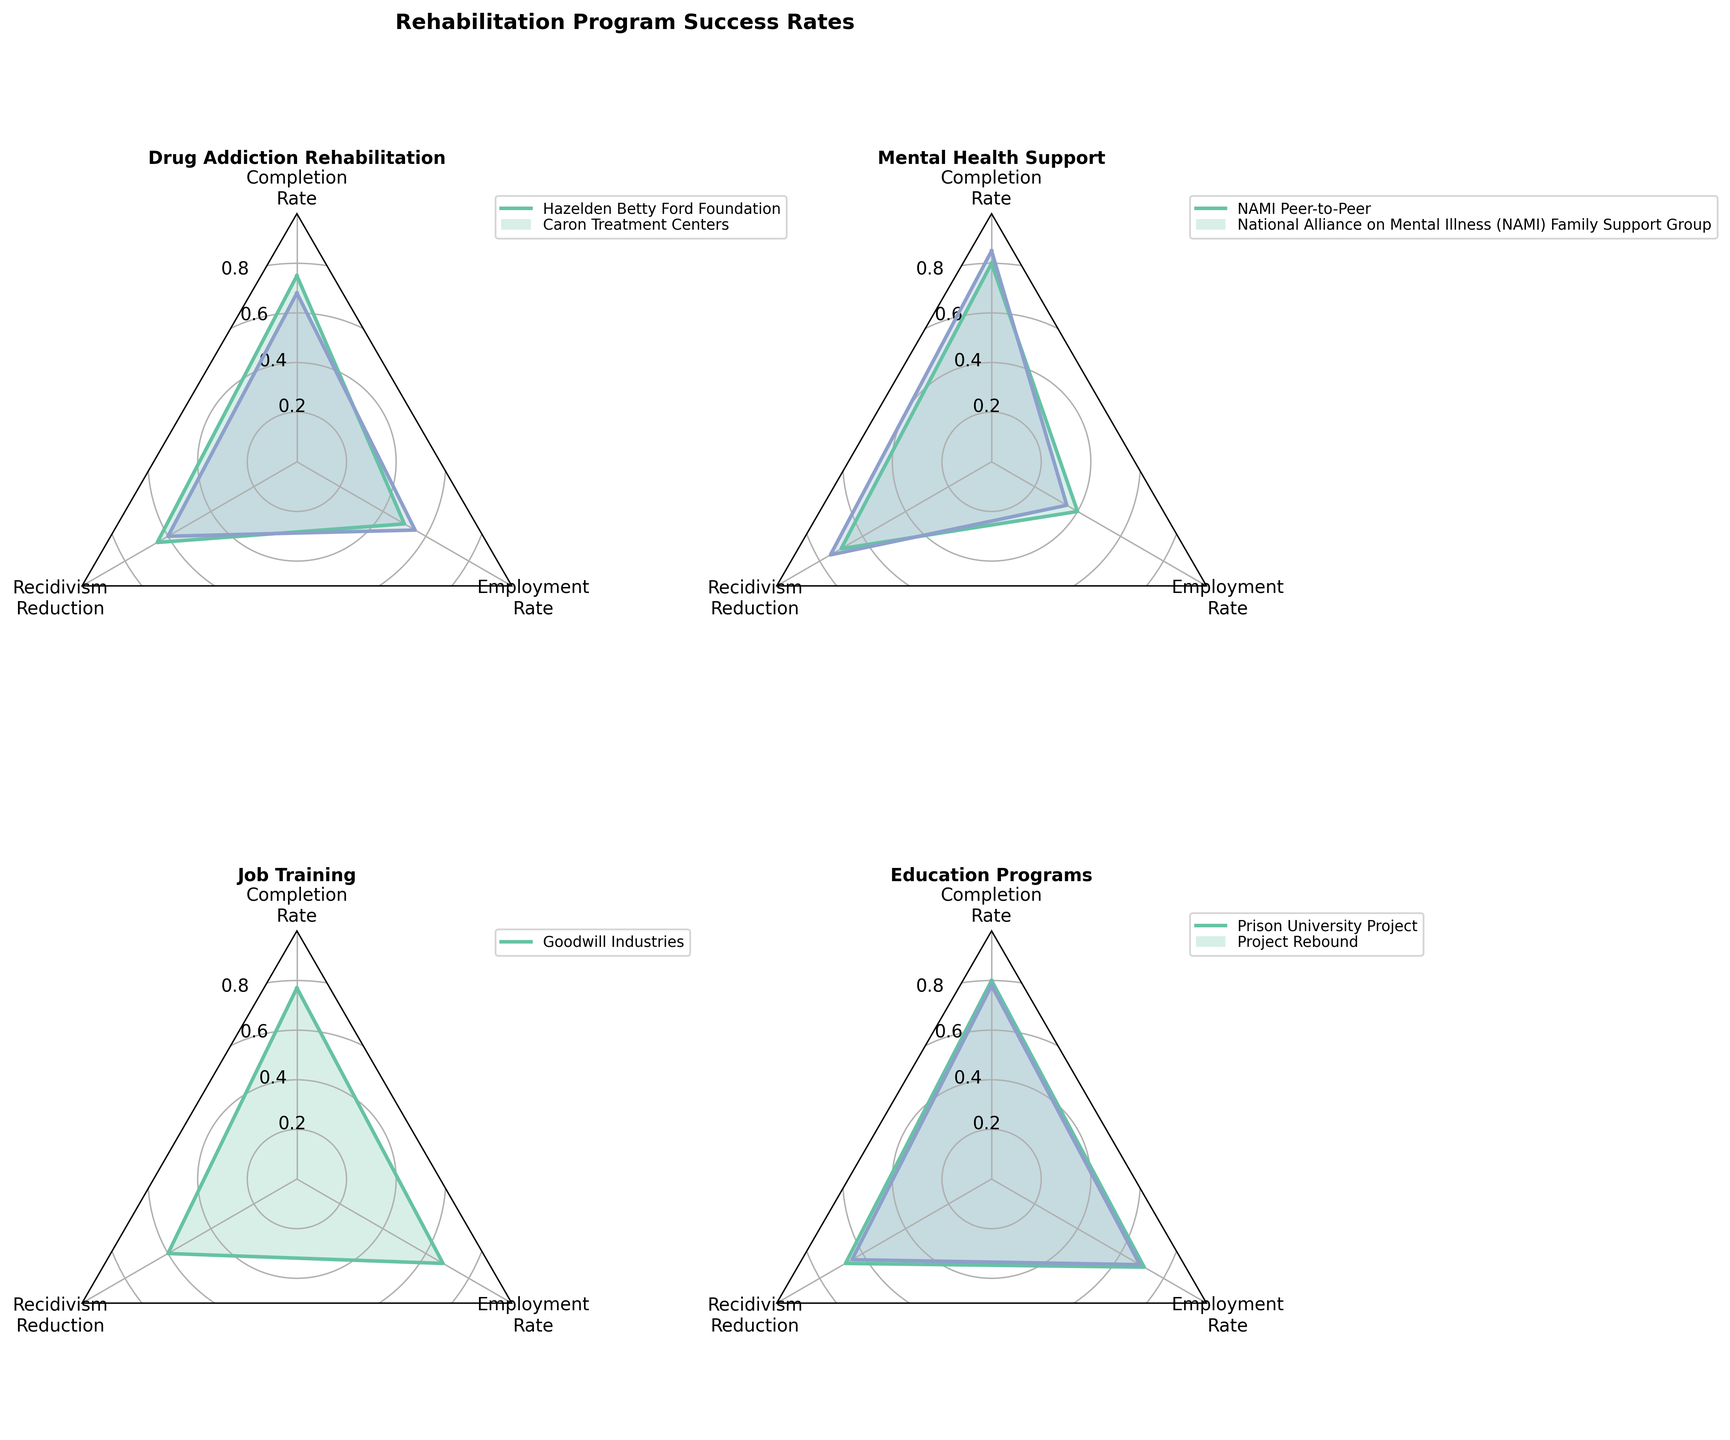What are the three metrics measured for each rehabilitation program? The radar charts measure each program’s success in three metrics, which are 'Completion Rate', 'Recidivism Reduction', and 'Employment Rate'. These metrics are key indicators of the programs’ impact on participants.
Answer: 'Completion Rate', 'Recidivism Reduction', and 'Employment Rate' Which mental health support program has the highest completion rate? Referring to the radar chart for 'Mental Health Support', both programs are displayed with their rates. The 'National Alliance on Mental Illness (NAMI) Family Support Group' has a completion rate of 85%, which is higher than NAMI Peer-to-Peer at 80%.
Answer: National Alliance on Mental Illness (NAMI) Family Support Group What's the difference in recidivism reduction rates between the two drug addiction rehabilitation programs? The 'Hazelden Betty Ford Foundation' has a recidivism reduction rate of 65%, and 'Caron Treatment Centers' has 60%. Thus, the difference is 65% - 60% = 5%.
Answer: 5% Which program shows the best overall success in reducing recidivism? By observing the 'Recidivism Reduction' metric across all programs in the radar charts, the 'National Alliance on Mental Illness (NAMI) Family Support Group' displays the highest recidivism reduction rate at 75%.
Answer: National Alliance on Mental Illness (NAMI) Family Support Group How do the employment rates compare between job training and education programs? Looking at the radar charts for 'Job Training' and 'Education Programs', we compare the employment rates. 'Goodwill Industries' (Job Training) has an employment rate of 68%, while 'Prison University Project' and 'Project Rebound' (Education Programs) have 71% and 69% respectively. Both education programs have slightly higher employment rates compared to the job training program.
Answer: Education programs have slightly higher employment rates Which type of rehabilitation program exhibits the highest average completion rate? To find the highest average completion rate, we calculate the means: 
Drug Addiction: (75% + 68%) / 2 = 71.5%, 
Mental Health: (80% + 85%) / 2 = 82.5%, 
Job Training: 77%, 
Education: (80% + 78%) / 2 = 79%. 
Mental Health programs average at 82.5%, which is the highest.
Answer: Mental Health Support Out of all programs, which one has the lowest employment rate and what is it? Examining the 'Employment Rate' for each program in the radar charts, the 'NAMI Peer-to-Peer' has the lowest rate at 40%.
Answer: NAMI Peer-to-Peer, 40% Which rehabilitation program shows an equal level of recidivism reduction and employment rate? By examining the radar charts, 'Caron Treatment Centers' exhibits equal values for both metrics with a rate of 55% for both recidivism reduction and employment.
Answer: Caron Treatment Centers How much higher is the completion rate of the Hazelden Betty Ford Foundation compared to Caron Treatment Centers? According to the chart for 'Drug Addiction Rehabilitation', 'Hazelden Betty Ford Foundation' has a completion rate of 75%, and 'Caron Treatment Centers' has 68%. The difference is 75% - 68% = 7%.
Answer: 7% 